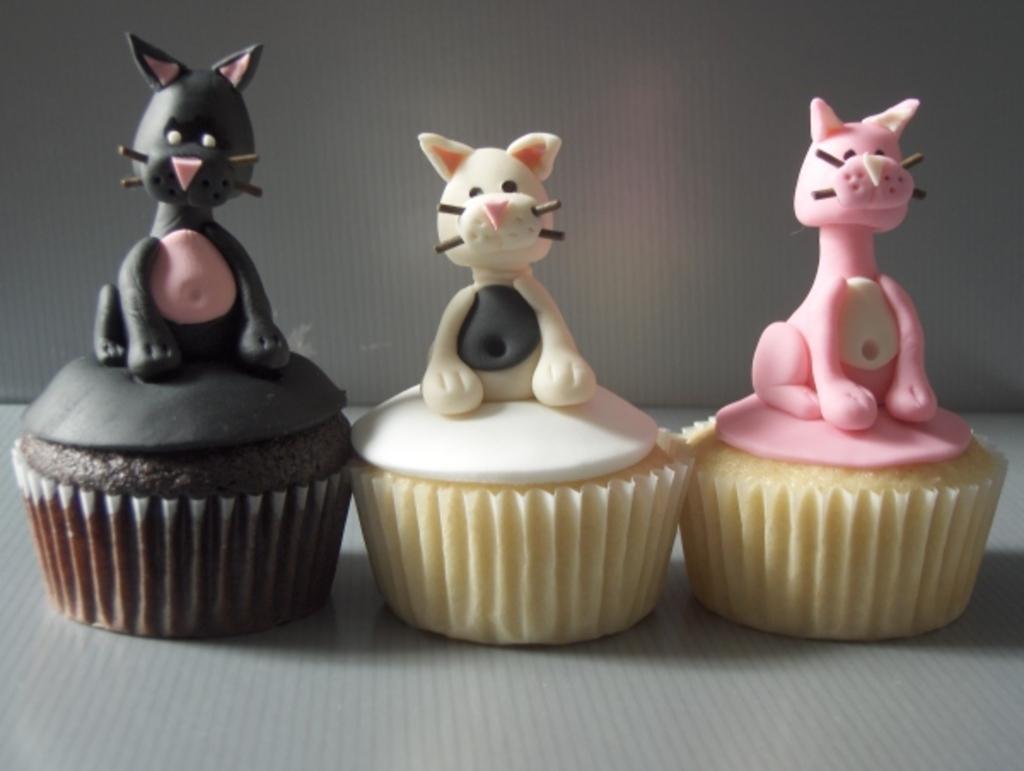Can you describe this image briefly? The picture consists of cupcakes, on the cakes there are structures of cats in different colors. At the bottom it maybe a table. 